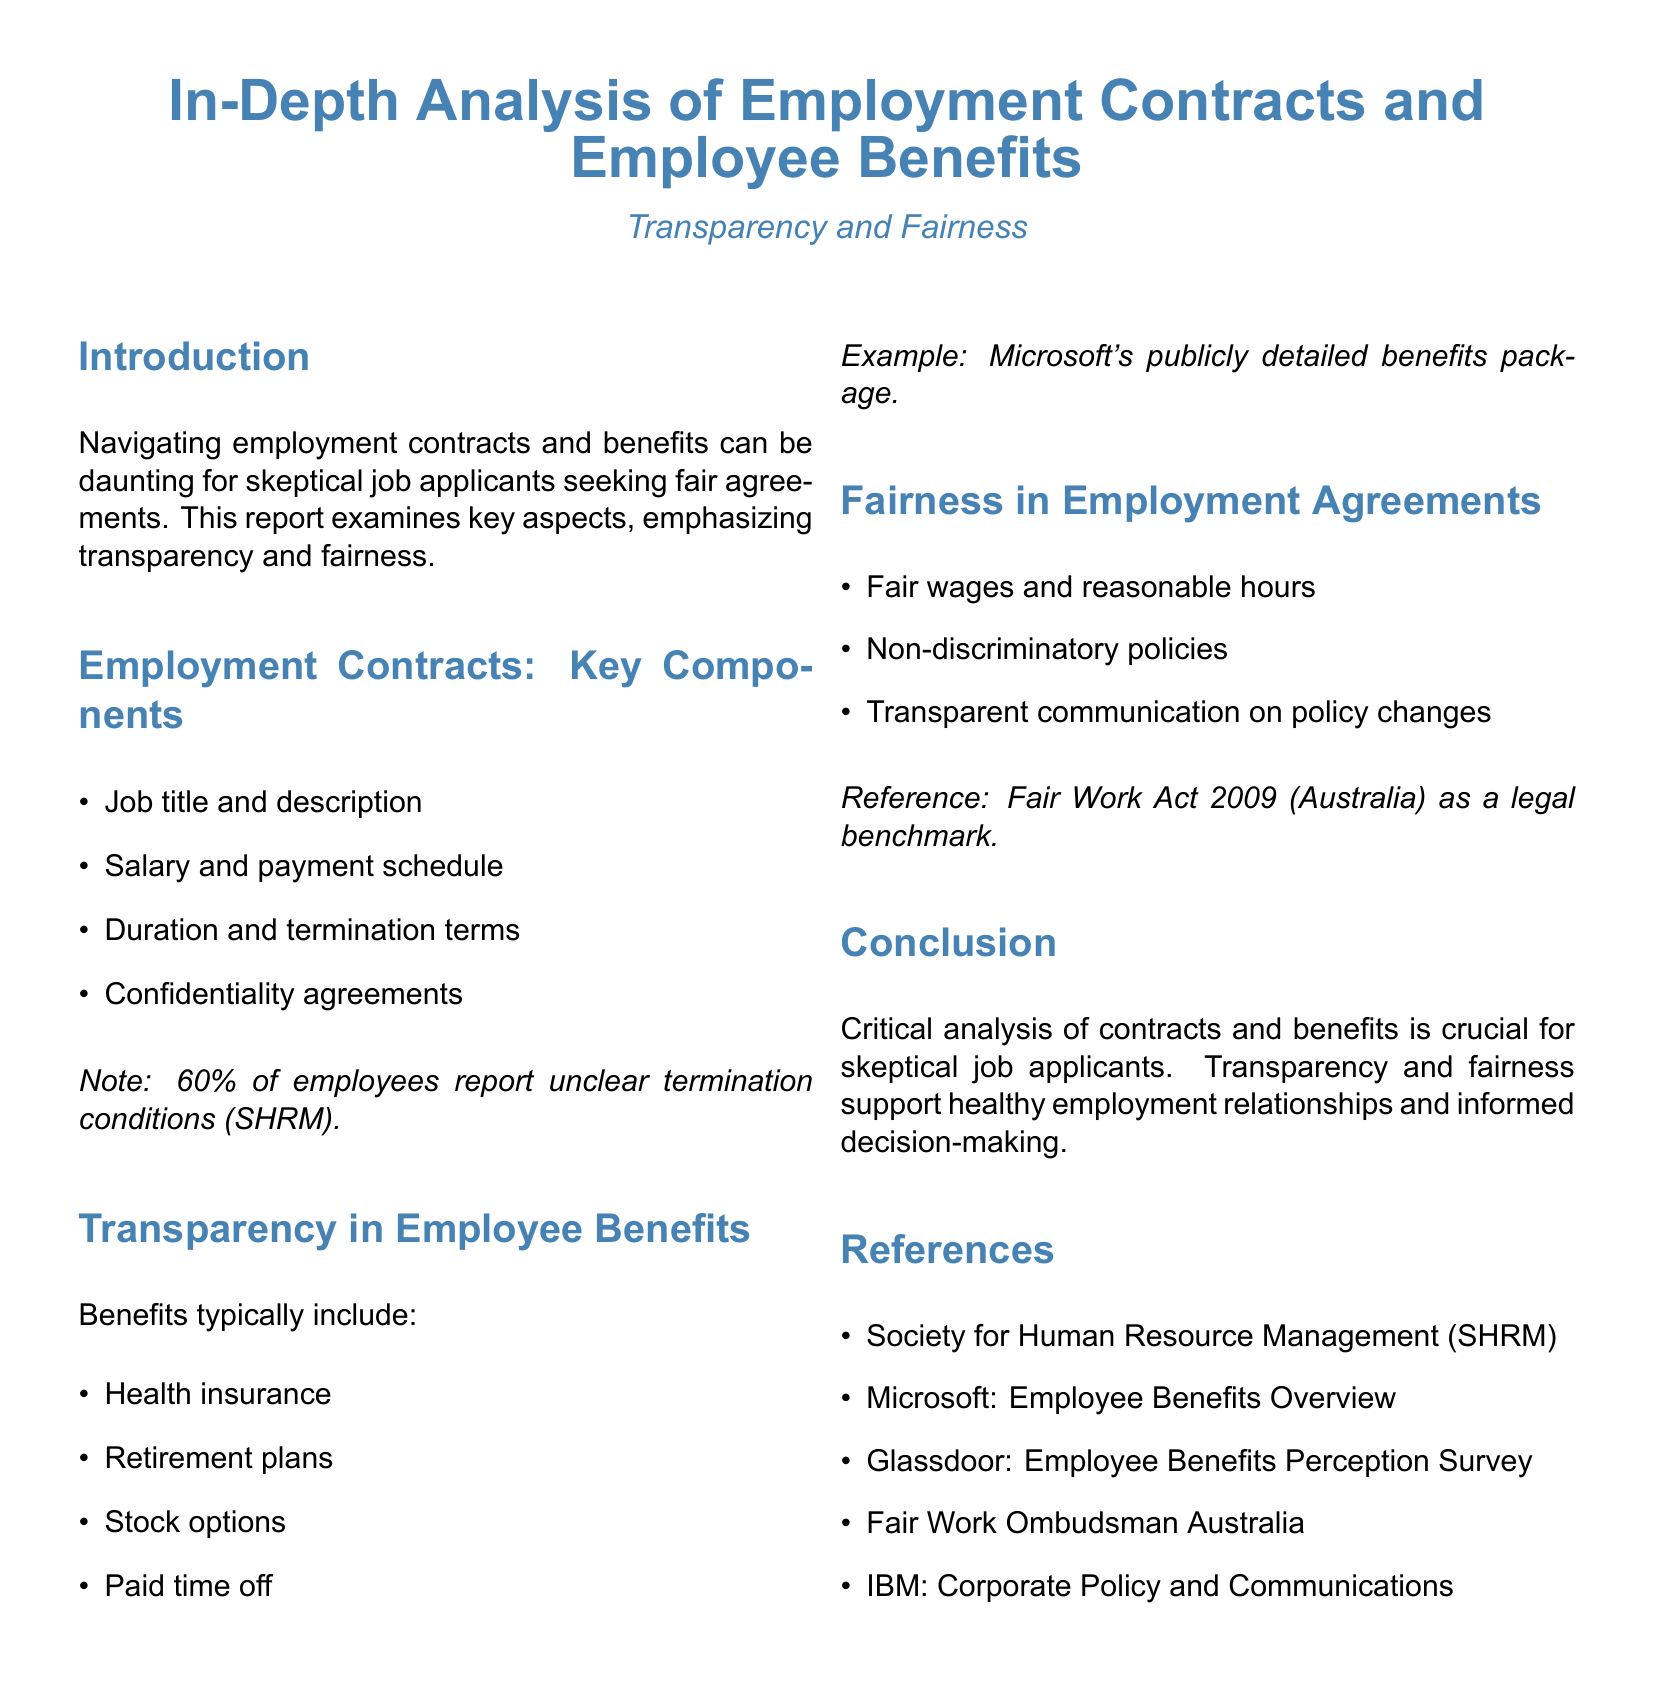What percentage of employees report unclear termination conditions? The document states that 60% of employees report unclear termination conditions according to SHRM.
Answer: 60% What are the key components of employment contracts? The document lists multiple key components, such as job title and description, salary and payment schedule, duration and termination terms, and confidentiality agreements.
Answer: Job title and description, salary and payment schedule, duration and termination terms, confidentiality agreements Which legal benchmark is referenced for fairness in employment agreements? The document references the Fair Work Act 2009 (Australia) as a legal benchmark for fairness in employment agreements.
Answer: Fair Work Act 2009 (Australia) What type of benefits does the document mention under transparency? The document mentions health insurance, retirement plans, stock options, and paid time off as types of benefits under transparency.
Answer: Health insurance, retirement plans, stock options, paid time off What is the main focus of this lab report? The main focus of the report is on transparency and fairness in employment contracts and employee benefits.
Answer: Transparency and fairness What is one example of a company with a publicly detailed benefits package? The document provides an example of Microsoft having a publicly detailed benefits package.
Answer: Microsoft 